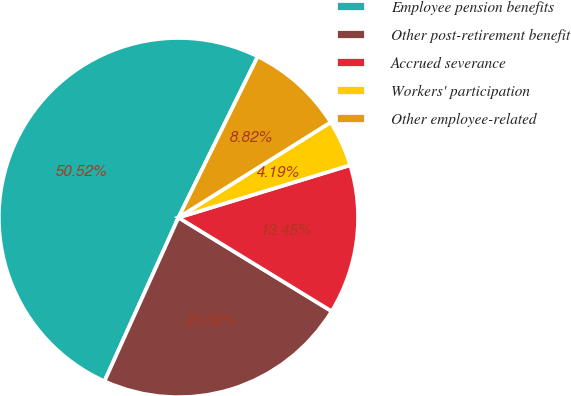Convert chart. <chart><loc_0><loc_0><loc_500><loc_500><pie_chart><fcel>Employee pension benefits<fcel>Other post-retirement benefit<fcel>Accrued severance<fcel>Workers' participation<fcel>Other employee-related<nl><fcel>50.52%<fcel>23.02%<fcel>13.45%<fcel>4.19%<fcel>8.82%<nl></chart> 